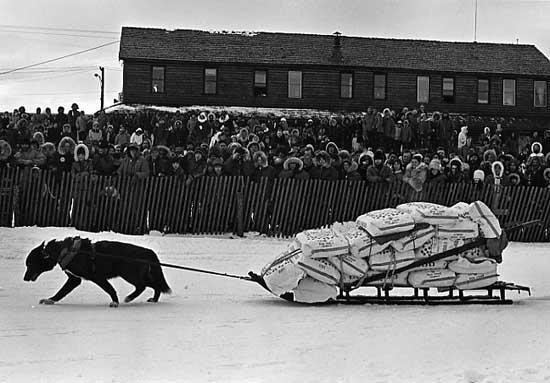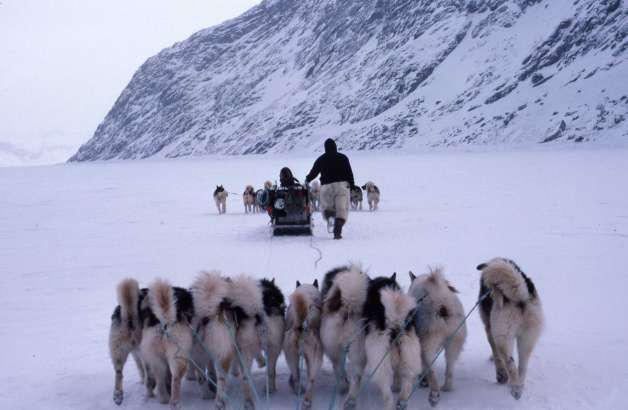The first image is the image on the left, the second image is the image on the right. Examine the images to the left and right. Is the description "There are more than four animals in harnesses." accurate? Answer yes or no. Yes. The first image is the image on the left, the second image is the image on the right. For the images shown, is this caption "The right image shows one person standing behind a small sled pulled by no more than two dogs and heading rightward." true? Answer yes or no. No. 